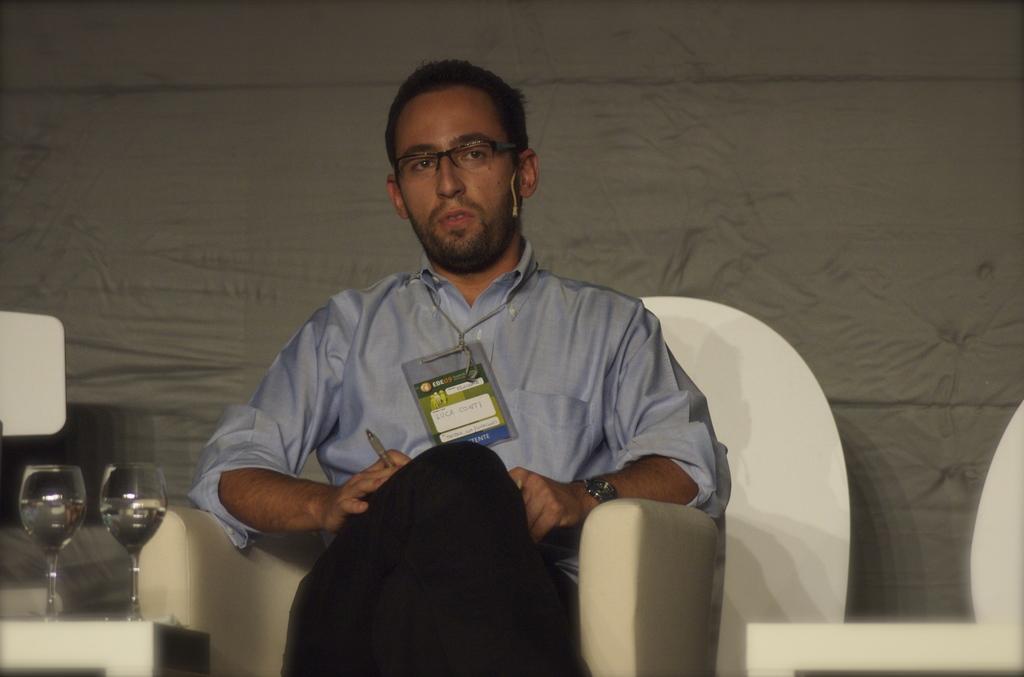Could you give a brief overview of what you see in this image? In this picture there is a man who is wearing shirt, trouser, spectacle and watch. He is sitting on the chair and holding a pen. In the bottom left corner I can see two wine glasses on the table. In the back I can see the grey wall. On the right and left side I can see the chairs. 